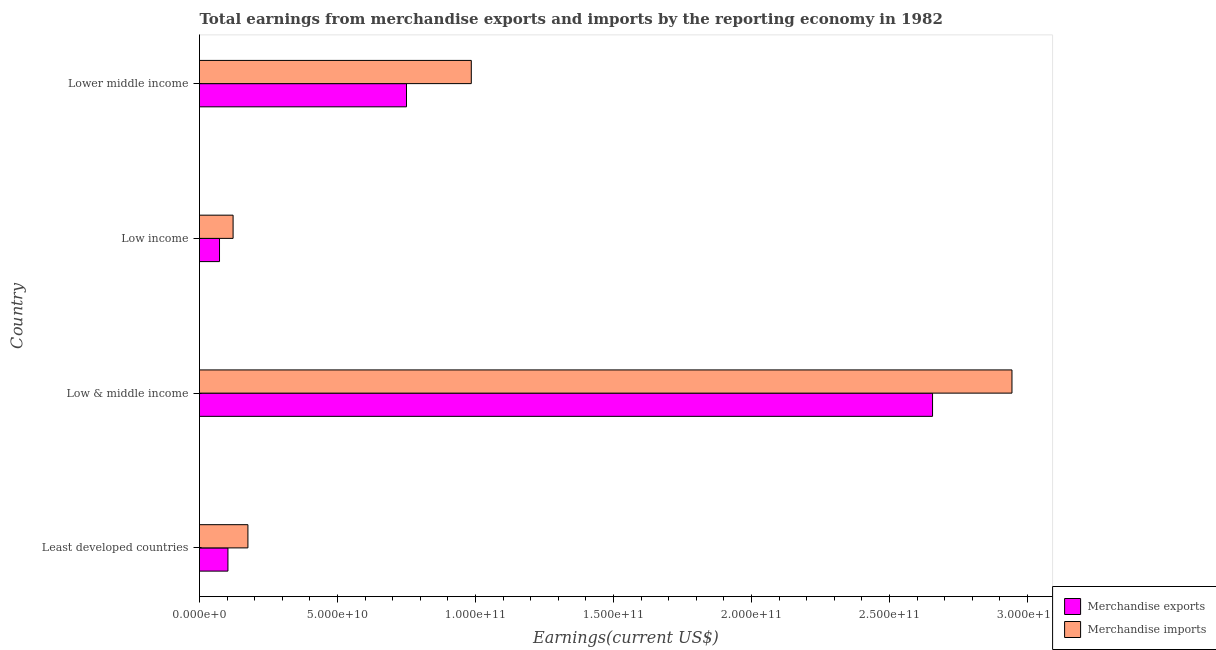How many different coloured bars are there?
Make the answer very short. 2. Are the number of bars on each tick of the Y-axis equal?
Offer a very short reply. Yes. How many bars are there on the 4th tick from the bottom?
Your response must be concise. 2. What is the earnings from merchandise imports in Lower middle income?
Give a very brief answer. 9.85e+1. Across all countries, what is the maximum earnings from merchandise exports?
Your response must be concise. 2.66e+11. Across all countries, what is the minimum earnings from merchandise imports?
Your answer should be very brief. 1.22e+1. In which country was the earnings from merchandise imports maximum?
Make the answer very short. Low & middle income. What is the total earnings from merchandise exports in the graph?
Keep it short and to the point. 3.58e+11. What is the difference between the earnings from merchandise exports in Low income and that in Lower middle income?
Provide a short and direct response. -6.77e+1. What is the difference between the earnings from merchandise exports in Low & middle income and the earnings from merchandise imports in Least developed countries?
Your answer should be compact. 2.48e+11. What is the average earnings from merchandise imports per country?
Your answer should be compact. 1.06e+11. What is the difference between the earnings from merchandise exports and earnings from merchandise imports in Least developed countries?
Provide a short and direct response. -7.24e+09. In how many countries, is the earnings from merchandise exports greater than 240000000000 US$?
Your answer should be compact. 1. What is the ratio of the earnings from merchandise exports in Low & middle income to that in Lower middle income?
Give a very brief answer. 3.54. Is the earnings from merchandise imports in Low income less than that in Lower middle income?
Offer a very short reply. Yes. Is the difference between the earnings from merchandise exports in Low & middle income and Low income greater than the difference between the earnings from merchandise imports in Low & middle income and Low income?
Ensure brevity in your answer.  No. What is the difference between the highest and the second highest earnings from merchandise imports?
Provide a succinct answer. 1.96e+11. What is the difference between the highest and the lowest earnings from merchandise imports?
Your answer should be compact. 2.82e+11. Is the sum of the earnings from merchandise imports in Low income and Lower middle income greater than the maximum earnings from merchandise exports across all countries?
Your answer should be compact. No. How many bars are there?
Your answer should be very brief. 8. What is the difference between two consecutive major ticks on the X-axis?
Provide a short and direct response. 5.00e+1. Are the values on the major ticks of X-axis written in scientific E-notation?
Your response must be concise. Yes. Does the graph contain any zero values?
Provide a short and direct response. No. Where does the legend appear in the graph?
Give a very brief answer. Bottom right. How many legend labels are there?
Your answer should be compact. 2. What is the title of the graph?
Provide a succinct answer. Total earnings from merchandise exports and imports by the reporting economy in 1982. What is the label or title of the X-axis?
Your answer should be very brief. Earnings(current US$). What is the label or title of the Y-axis?
Your answer should be compact. Country. What is the Earnings(current US$) of Merchandise exports in Least developed countries?
Offer a very short reply. 1.03e+1. What is the Earnings(current US$) of Merchandise imports in Least developed countries?
Ensure brevity in your answer.  1.75e+1. What is the Earnings(current US$) in Merchandise exports in Low & middle income?
Provide a short and direct response. 2.66e+11. What is the Earnings(current US$) of Merchandise imports in Low & middle income?
Keep it short and to the point. 2.94e+11. What is the Earnings(current US$) in Merchandise exports in Low income?
Your response must be concise. 7.25e+09. What is the Earnings(current US$) in Merchandise imports in Low income?
Give a very brief answer. 1.22e+1. What is the Earnings(current US$) in Merchandise exports in Lower middle income?
Make the answer very short. 7.50e+1. What is the Earnings(current US$) of Merchandise imports in Lower middle income?
Give a very brief answer. 9.85e+1. Across all countries, what is the maximum Earnings(current US$) in Merchandise exports?
Provide a succinct answer. 2.66e+11. Across all countries, what is the maximum Earnings(current US$) in Merchandise imports?
Make the answer very short. 2.94e+11. Across all countries, what is the minimum Earnings(current US$) in Merchandise exports?
Offer a very short reply. 7.25e+09. Across all countries, what is the minimum Earnings(current US$) of Merchandise imports?
Offer a very short reply. 1.22e+1. What is the total Earnings(current US$) in Merchandise exports in the graph?
Offer a terse response. 3.58e+11. What is the total Earnings(current US$) of Merchandise imports in the graph?
Give a very brief answer. 4.23e+11. What is the difference between the Earnings(current US$) in Merchandise exports in Least developed countries and that in Low & middle income?
Provide a short and direct response. -2.55e+11. What is the difference between the Earnings(current US$) in Merchandise imports in Least developed countries and that in Low & middle income?
Make the answer very short. -2.77e+11. What is the difference between the Earnings(current US$) in Merchandise exports in Least developed countries and that in Low income?
Your response must be concise. 3.05e+09. What is the difference between the Earnings(current US$) of Merchandise imports in Least developed countries and that in Low income?
Your response must be concise. 5.37e+09. What is the difference between the Earnings(current US$) of Merchandise exports in Least developed countries and that in Lower middle income?
Offer a very short reply. -6.47e+1. What is the difference between the Earnings(current US$) in Merchandise imports in Least developed countries and that in Lower middle income?
Provide a short and direct response. -8.09e+1. What is the difference between the Earnings(current US$) of Merchandise exports in Low & middle income and that in Low income?
Ensure brevity in your answer.  2.58e+11. What is the difference between the Earnings(current US$) of Merchandise imports in Low & middle income and that in Low income?
Make the answer very short. 2.82e+11. What is the difference between the Earnings(current US$) of Merchandise exports in Low & middle income and that in Lower middle income?
Make the answer very short. 1.91e+11. What is the difference between the Earnings(current US$) in Merchandise imports in Low & middle income and that in Lower middle income?
Keep it short and to the point. 1.96e+11. What is the difference between the Earnings(current US$) in Merchandise exports in Low income and that in Lower middle income?
Your response must be concise. -6.77e+1. What is the difference between the Earnings(current US$) in Merchandise imports in Low income and that in Lower middle income?
Provide a short and direct response. -8.63e+1. What is the difference between the Earnings(current US$) of Merchandise exports in Least developed countries and the Earnings(current US$) of Merchandise imports in Low & middle income?
Your answer should be very brief. -2.84e+11. What is the difference between the Earnings(current US$) in Merchandise exports in Least developed countries and the Earnings(current US$) in Merchandise imports in Low income?
Ensure brevity in your answer.  -1.87e+09. What is the difference between the Earnings(current US$) of Merchandise exports in Least developed countries and the Earnings(current US$) of Merchandise imports in Lower middle income?
Ensure brevity in your answer.  -8.82e+1. What is the difference between the Earnings(current US$) of Merchandise exports in Low & middle income and the Earnings(current US$) of Merchandise imports in Low income?
Provide a short and direct response. 2.53e+11. What is the difference between the Earnings(current US$) of Merchandise exports in Low & middle income and the Earnings(current US$) of Merchandise imports in Lower middle income?
Offer a terse response. 1.67e+11. What is the difference between the Earnings(current US$) in Merchandise exports in Low income and the Earnings(current US$) in Merchandise imports in Lower middle income?
Provide a short and direct response. -9.12e+1. What is the average Earnings(current US$) in Merchandise exports per country?
Make the answer very short. 8.95e+1. What is the average Earnings(current US$) of Merchandise imports per country?
Make the answer very short. 1.06e+11. What is the difference between the Earnings(current US$) in Merchandise exports and Earnings(current US$) in Merchandise imports in Least developed countries?
Provide a short and direct response. -7.24e+09. What is the difference between the Earnings(current US$) of Merchandise exports and Earnings(current US$) of Merchandise imports in Low & middle income?
Give a very brief answer. -2.88e+1. What is the difference between the Earnings(current US$) in Merchandise exports and Earnings(current US$) in Merchandise imports in Low income?
Your answer should be compact. -4.92e+09. What is the difference between the Earnings(current US$) in Merchandise exports and Earnings(current US$) in Merchandise imports in Lower middle income?
Your answer should be very brief. -2.35e+1. What is the ratio of the Earnings(current US$) of Merchandise exports in Least developed countries to that in Low & middle income?
Give a very brief answer. 0.04. What is the ratio of the Earnings(current US$) of Merchandise imports in Least developed countries to that in Low & middle income?
Offer a very short reply. 0.06. What is the ratio of the Earnings(current US$) in Merchandise exports in Least developed countries to that in Low income?
Provide a short and direct response. 1.42. What is the ratio of the Earnings(current US$) in Merchandise imports in Least developed countries to that in Low income?
Your answer should be compact. 1.44. What is the ratio of the Earnings(current US$) of Merchandise exports in Least developed countries to that in Lower middle income?
Keep it short and to the point. 0.14. What is the ratio of the Earnings(current US$) in Merchandise imports in Least developed countries to that in Lower middle income?
Your response must be concise. 0.18. What is the ratio of the Earnings(current US$) in Merchandise exports in Low & middle income to that in Low income?
Keep it short and to the point. 36.65. What is the ratio of the Earnings(current US$) of Merchandise imports in Low & middle income to that in Low income?
Offer a terse response. 24.19. What is the ratio of the Earnings(current US$) of Merchandise exports in Low & middle income to that in Lower middle income?
Offer a very short reply. 3.54. What is the ratio of the Earnings(current US$) of Merchandise imports in Low & middle income to that in Lower middle income?
Your answer should be very brief. 2.99. What is the ratio of the Earnings(current US$) in Merchandise exports in Low income to that in Lower middle income?
Make the answer very short. 0.1. What is the ratio of the Earnings(current US$) of Merchandise imports in Low income to that in Lower middle income?
Give a very brief answer. 0.12. What is the difference between the highest and the second highest Earnings(current US$) in Merchandise exports?
Your answer should be compact. 1.91e+11. What is the difference between the highest and the second highest Earnings(current US$) of Merchandise imports?
Offer a very short reply. 1.96e+11. What is the difference between the highest and the lowest Earnings(current US$) of Merchandise exports?
Your answer should be very brief. 2.58e+11. What is the difference between the highest and the lowest Earnings(current US$) of Merchandise imports?
Your response must be concise. 2.82e+11. 